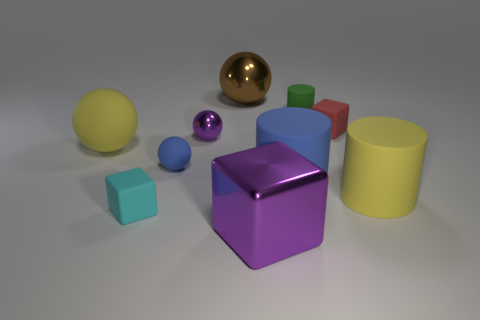Subtract all cylinders. How many objects are left? 7 Add 1 tiny green matte spheres. How many tiny green matte spheres exist? 1 Subtract 0 cyan spheres. How many objects are left? 10 Subtract all tiny shiny things. Subtract all matte objects. How many objects are left? 2 Add 2 large blue rubber things. How many large blue rubber things are left? 3 